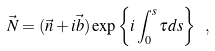<formula> <loc_0><loc_0><loc_500><loc_500>\vec { N } = ( \vec { n } + i \vec { b } ) \exp \left \{ i \int _ { 0 } ^ { s } \tau d s \right \} \ ,</formula> 